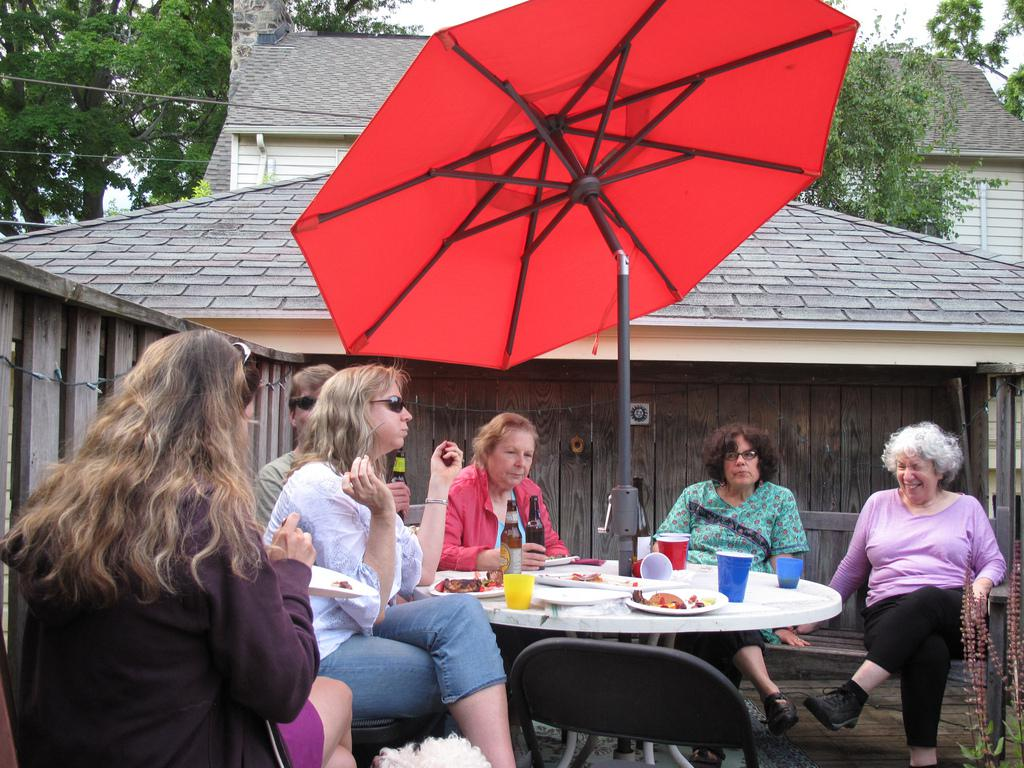Question: where is this located?
Choices:
A. Backyard.
B. Frontyard.
C. On the side of the house.
D. On the porch.
Answer with the letter. Answer: A Question: where is the umbrella?
Choices:
A. On the table.
B. In the trunk.
C. Leaning against the wall.
D. Inside the house.
Answer with the letter. Answer: A Question: how many men are there?
Choices:
A. One.
B. Two.
C. Three.
D. Four.
Answer with the letter. Answer: A Question: what color are the cups?
Choices:
A. Green.
B. Black and white.
C. Orange and pruple.
D. Red, yellow and blue.
Answer with the letter. Answer: D Question: what is roof made of?
Choices:
A. Shingle.
B. Tile.
C. Ply wood.
D. Thatch.
Answer with the letter. Answer: A Question: what the man holding?
Choices:
A. Car keys.
B. A mug.
C. A beer.
D. A bottle.
Answer with the letter. Answer: C Question: how many ladies are sitting on a wooden bench?
Choices:
A. Three.
B. One.
C. Two.
D. Zero.
Answer with the letter. Answer: C Question: how many women are laughing?
Choices:
A. Two.
B. One.
C. Four.
D. None.
Answer with the letter. Answer: B Question: how many women have their legs crossed?
Choices:
A. Four.
B. Two.
C. Three.
D. One.
Answer with the letter. Answer: A Question: what are the group of friends doing?
Choices:
A. Smoking and watching.
B. Drinking and laughing.
C. Breathing and waiting.
D. Eating and chatting.
Answer with the letter. Answer: D Question: how many bottles of beer are there?
Choices:
A. Six.
B. Nine.
C. Three.
D. Two.
Answer with the letter. Answer: C Question: where is the fence?
Choices:
A. On the right side of the people.
B. On the left side of the truck.
C. On the left side of the people.
D. In the background.
Answer with the letter. Answer: C Question: what is outdoors?
Choices:
A. The dog.
B. The snow.
C. The car.
D. The scene.
Answer with the letter. Answer: D Question: who has on sunglasses?
Choices:
A. The police officer.
B. The lifeguard.
C. The small child.
D. A couple of people.
Answer with the letter. Answer: D Question: how many people are around the table?
Choices:
A. Six.
B. Five.
C. Seven.
D. Four.
Answer with the letter. Answer: A Question: who has curly hair?
Choices:
A. The baby.
B. Two women.
C. The clown.
D. The young man.
Answer with the letter. Answer: B Question: who is not smiling?
Choices:
A. Three women.
B. The judge.
C. The police officer.
D. The teacher.
Answer with the letter. Answer: A 